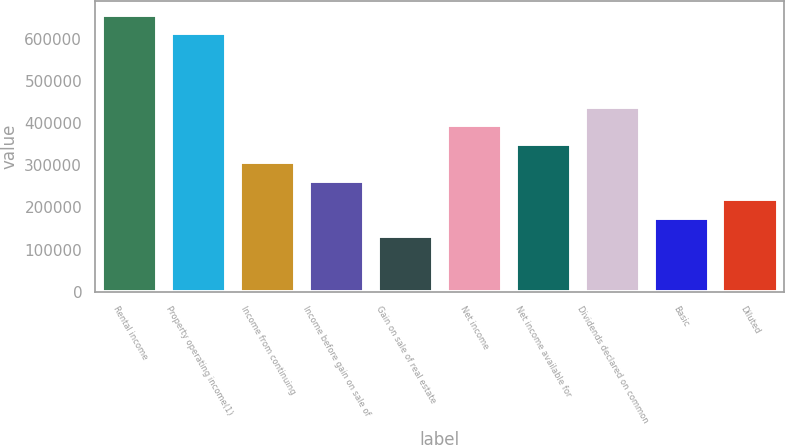Convert chart. <chart><loc_0><loc_0><loc_500><loc_500><bar_chart><fcel>Rental income<fcel>Property operating income(1)<fcel>Income from continuing<fcel>Income before gain on sale of<fcel>Gain on sale of real estate<fcel>Net income<fcel>Net income available for<fcel>Dividends declared on common<fcel>Basic<fcel>Diluted<nl><fcel>657301<fcel>613481<fcel>306741<fcel>262921<fcel>131461<fcel>394381<fcel>350561<fcel>438201<fcel>175281<fcel>219101<nl></chart> 